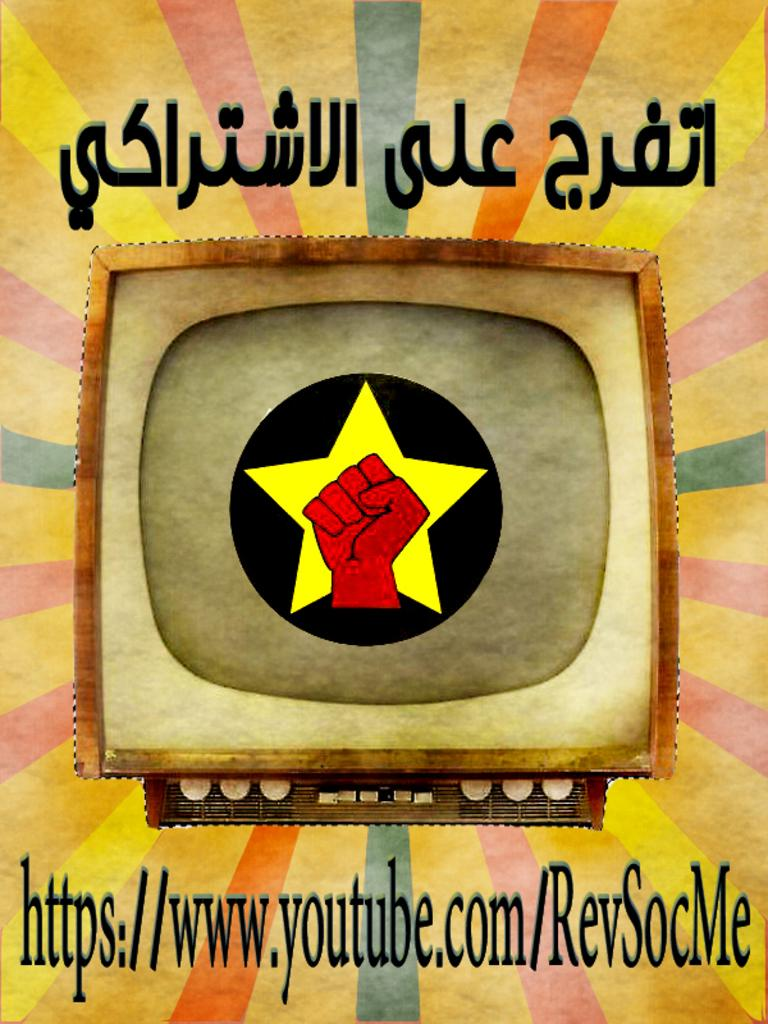Provide a one-sentence caption for the provided image. An ad for RevSocMe on Youtube shows a red fist against a yellow star. 